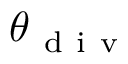Convert formula to latex. <formula><loc_0><loc_0><loc_500><loc_500>\theta _ { d i v }</formula> 